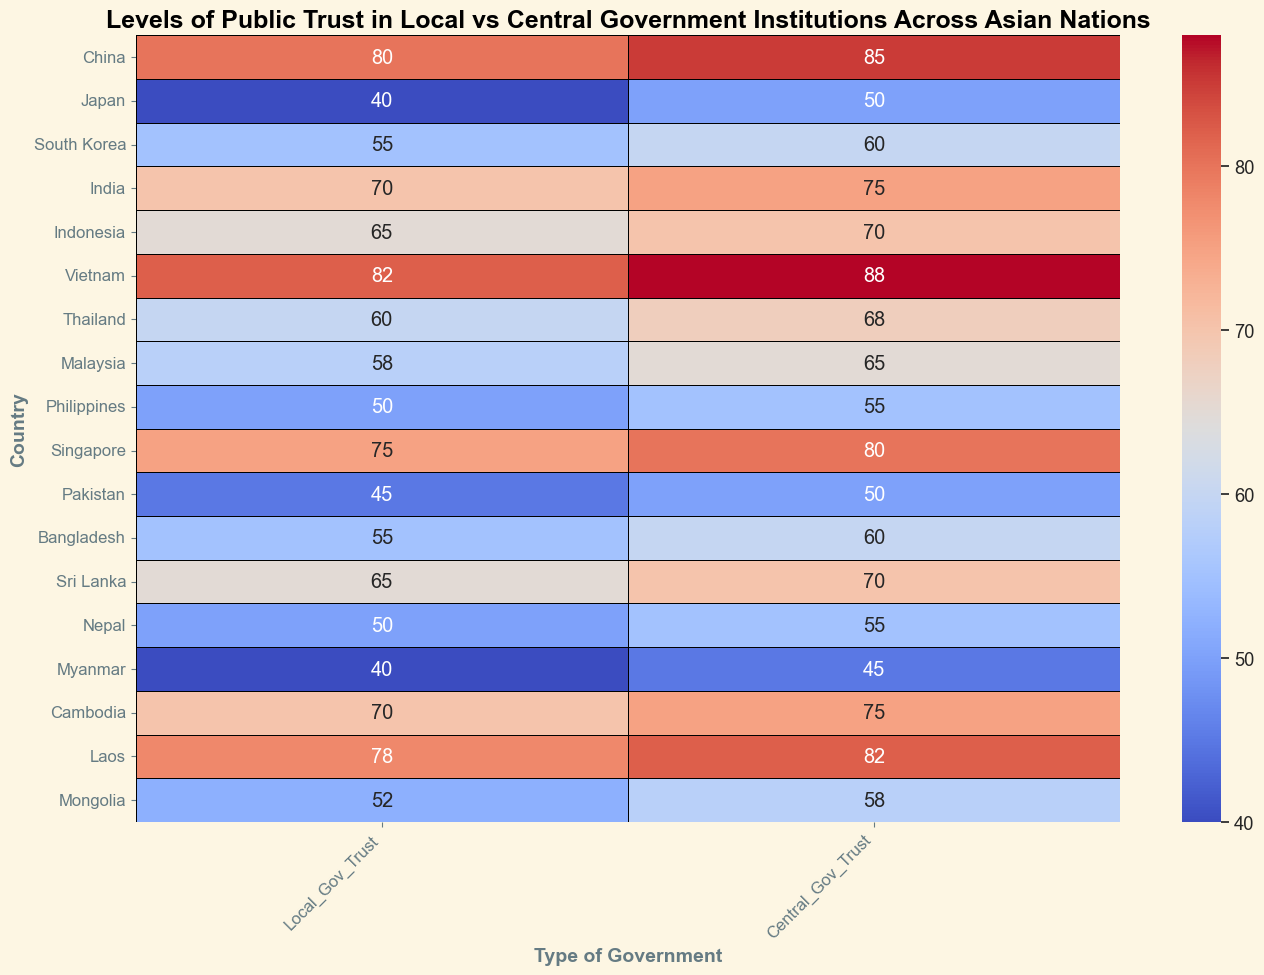Which country has the highest level of trust in both local and central government institutions? To find the country with the highest level of trust in both local and central government, look for the country with the highest values on both axes. Here, Vietnam has 82 (local) and 88 (central), which are the highest combined trust levels.
Answer: Vietnam Which country shows the largest difference between local and central government trust levels? Calculate the difference between local and central trust levels for each country and find the largest value. The differences are: China (5), Japan (10), South Korea (5), India (5), Indonesia (5), Vietnam (6), Thailand (8), Malaysia (7), Philippines (5), Singapore (5), Pakistan (5), Bangladesh (5), Sri Lanka (5), Nepal (5), Myanmar (5), Cambodia (5), Laos (4), Mongolia (6). The largest difference is Japan with 10.
Answer: Japan What is the average trust level in local government across all nations? Sum of the trust levels in local government for all countries is 1030. There are 18 countries. So, the average trust level is 1030/18 = 57.22.
Answer: 57.22 Which countries have higher trust in local government than central government? Compare the trust levels of local and central government for each country. Countries with higher local government trust are China, Vietnam, Thailand, Cambodia, and Laos.
Answer: China, Vietnam, Thailand, Cambodia, Laos Which three countries have the lowest trust levels in both local and central government combined? Add the trust levels for local and central government for each country and sort them. The lowest combined scores are Myanmar (85), Pakistan (95), and Japan/Nepal (90+95).
Answer: Myanmar, Pakistan, Japan/Nepal Which country has the most equal level of trust between local and central government? Find the country with the smallest difference between local and central trust levels. Laos has a difference of 4, which is the smallest.
Answer: Laos What is the combined average trust level of local and central government in Indonesia and Malaysia? Calculate the average trust level for both countries combined. For Indonesia: (65+70)/2 = 67.5, and for Malaysia: (58+65)/2 = 61.5. Then, take the average of these two values: (67.5+61.5)/2 = 64.5.
Answer: 64.5 How many countries have a central government trust level greater than 60? Count the number of countries where the central government trust level is greater than 60. There are 10 countries: China, South Korea, India, Indonesia, Vietnam, Thailand, Malaysia, Singapore, Sri Lanka, Laos.
Answer: 10 Which country has a higher trust level in local government: Japan or the Philippines? Compare the local government trust levels of Japan (40) and Philippines (50). Philippines has a higher trust level.
Answer: Philippines Which country has the least difference between local and central government trust levels? Calculate the difference between trust levels for each country and find the smallest difference. Laos has the smallest difference of 4.
Answer: Laos 